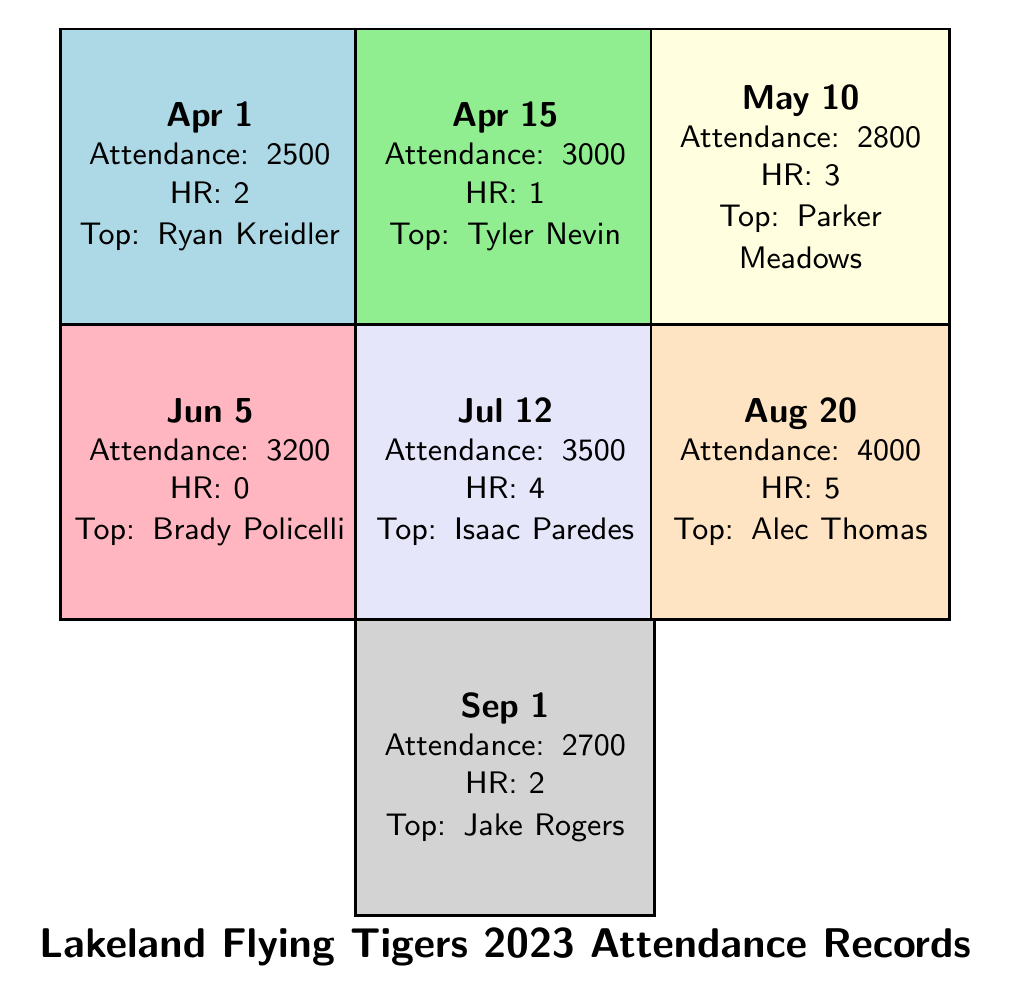What was the highest attendance at a Lakeland Flying Tigers game in 2023? The attendance records show that the highest attendance was on August 20, 2023, with 4000 attendees.
Answer: 4000 Which player had the most home runs hit during a single game? Looking at the records, Alec Thomas hit the most home runs in one game on August 20, with 5 home runs.
Answer: 5 What was the average attendance across all games? To find the average attendance, we sum the attendances: 2500 + 3000 + 2800 + 3200 + 3500 + 4000 + 2700 = 20700. There are 7 games, so the average is 20700 / 7 = 2957.14. Rounded, the average attendance is approximately 2957.
Answer: 2957 Did any game have zero home runs hit? Yes, the game on June 5, 2023, against the Palm Beach Cardinals had zero home runs hit.
Answer: Yes Which opponent had the lowest attendance? The attendance records show that the game against the Dunedin Blue Jays on April 1 had the lowest attendance of 2500.
Answer: 2500 What was the total number of home runs hit during the games? By adding up the home runs from all games: 2 + 1 + 3 + 0 + 4 + 5 + 2 = 17 home runs were hit in total.
Answer: 17 Which game had the top performer named Ryan Kreidler, and how many home runs were hit that day? Ryan Kreidler was the top performer in the game on April 1 against the Dunedin Blue Jays, where 2 home runs were hit.
Answer: April 1, 2 What is the difference in attendance between the highest and lowest attended games? The highest attendance was 4000 (August 20) and the lowest was 2500 (April 1). The difference is 4000 - 2500 = 1500.
Answer: 1500 Which month saw the most games played? Looking at the dates, there were games played in April (2 games), May (1 game), June (1 game), July (1 game), August (1 game), and September (1 game). April had the most games with 2.
Answer: April 